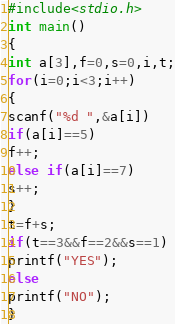Convert code to text. <code><loc_0><loc_0><loc_500><loc_500><_C_>#include<stdio.h>
int main()
{
int a[3],f=0,s=0,i,t;
for(i=0;i<3;i++)
{
scanf("%d ",&a[i])
if(a[i]==5)
f++;
else if(a[i]==7)
s++;
}
t=f+s;
if(t==3&&f==2&&s==1)
printf("YES");
else
printf("NO");
}</code> 